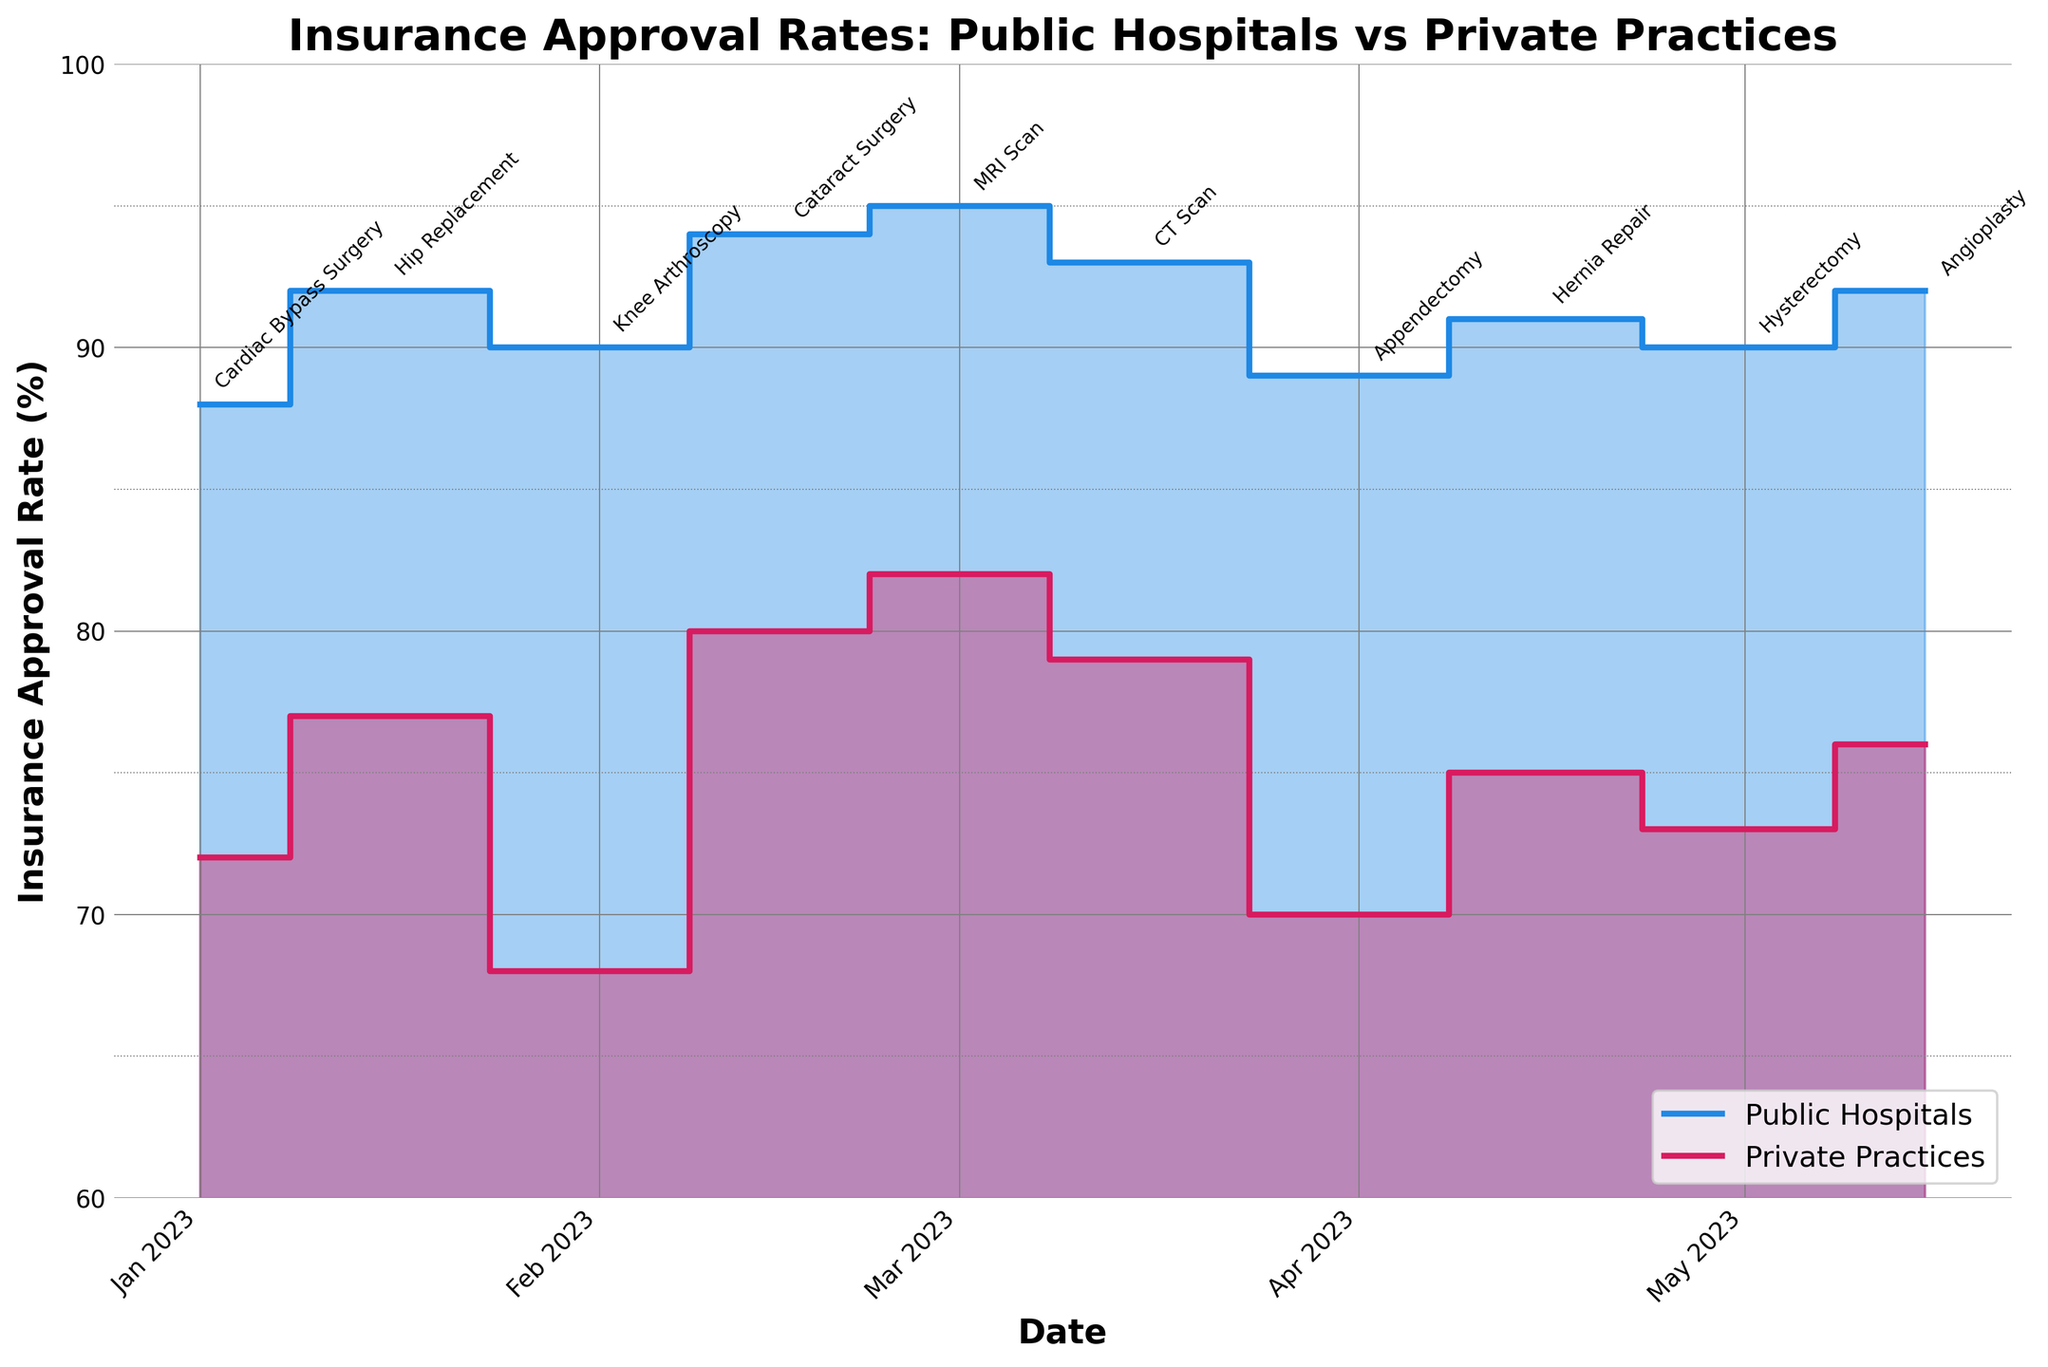What is the title of the chart? The title of the chart is displayed at the top and it reads "Insurance Approval Rates: Public Hospitals vs Private Practices".
Answer: Insurance Approval Rates: Public Hospitals vs Private Practices Which procedure conducted in private practices had the highest insurance approval rate? By looking at the step areas and annotations in the chart, the procedure in private practices with the highest insurance approval rate is indicated by the highest peak of the red line, which is MRI Scan at about 82%.
Answer: MRI Scan On which date was the insurance approval rate for Public Hospitals the highest? From the blue filled areas and corresponding dates, the highest approval rate for Public Hospitals appears around March 1, 2023, and it is 95%.
Answer: March 1, 2023 How much higher was the insurance approval rate for CT Scans in Public Hospitals compared to Private Practices? The approval rate for CT Scans in Public Hospitals is 93%, while for Private Practices it is 79%. The difference is 93 - 79 = 14%.
Answer: 14% What is the range of insurance approval rates for Private Practices? The lowest rate for Private Practices is 68% (Knee Arthroscopy) and the highest is 82% (MRI Scan). The range is 82 - 68 = 14%.
Answer: 14% Which procedure experienced the lowest approval rate in Public Hospitals? The step areas and annotations show the lowest point for Public Hospitals, which is found in the Cardiac Bypass Surgery on January 1, 2023, with an approval rate of 88%.
Answer: Cardiac Bypass Surgery Are there any dates where the insurance approval rates for Public Hospitals and Private Practices were equal? By visually comparing the steps of both lines, we do not see any points where the rates are equal.
Answer: No If you averaged the insurance approval rates for Public Hospitals and Private Practices on the date of Cataract Surgery, what would it be? The rates on February 15, 2023, are 94% for Public Hospitals and 80% for Private Practices. The average is (94 + 80) / 2 = 87%.
Answer: 87% By how much percent does the insurance approval rate for Hysterectomy differ between Public Hospitals and Private Practices? The insurance approval rate for Hysterectomy in Public Hospitals is 90%, and for Private Practices, it is 73%. The difference is 90 - 73 = 17%.
Answer: 17% Considering the trend depicted in the chart, do Public Hospitals consistently have higher insurance approval rates than Private Practices? The blue line representing Public Hospitals is consistently above the red line for Private Practices from January 1, 2023, to May 15, 2023, indicating that Public Hospitals consistently have higher insurance approval rates.
Answer: Yes 